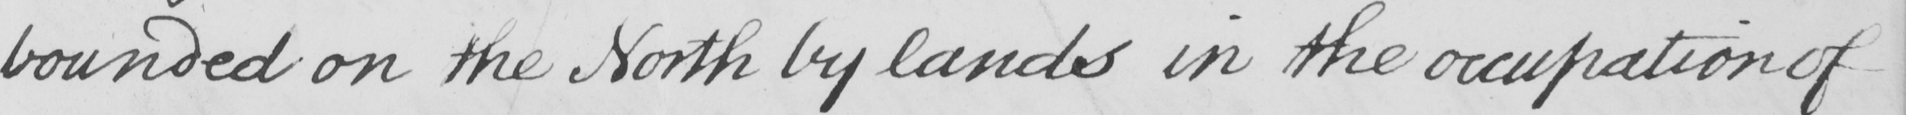Please transcribe the handwritten text in this image. bounded on the North by lands in the occupation of 